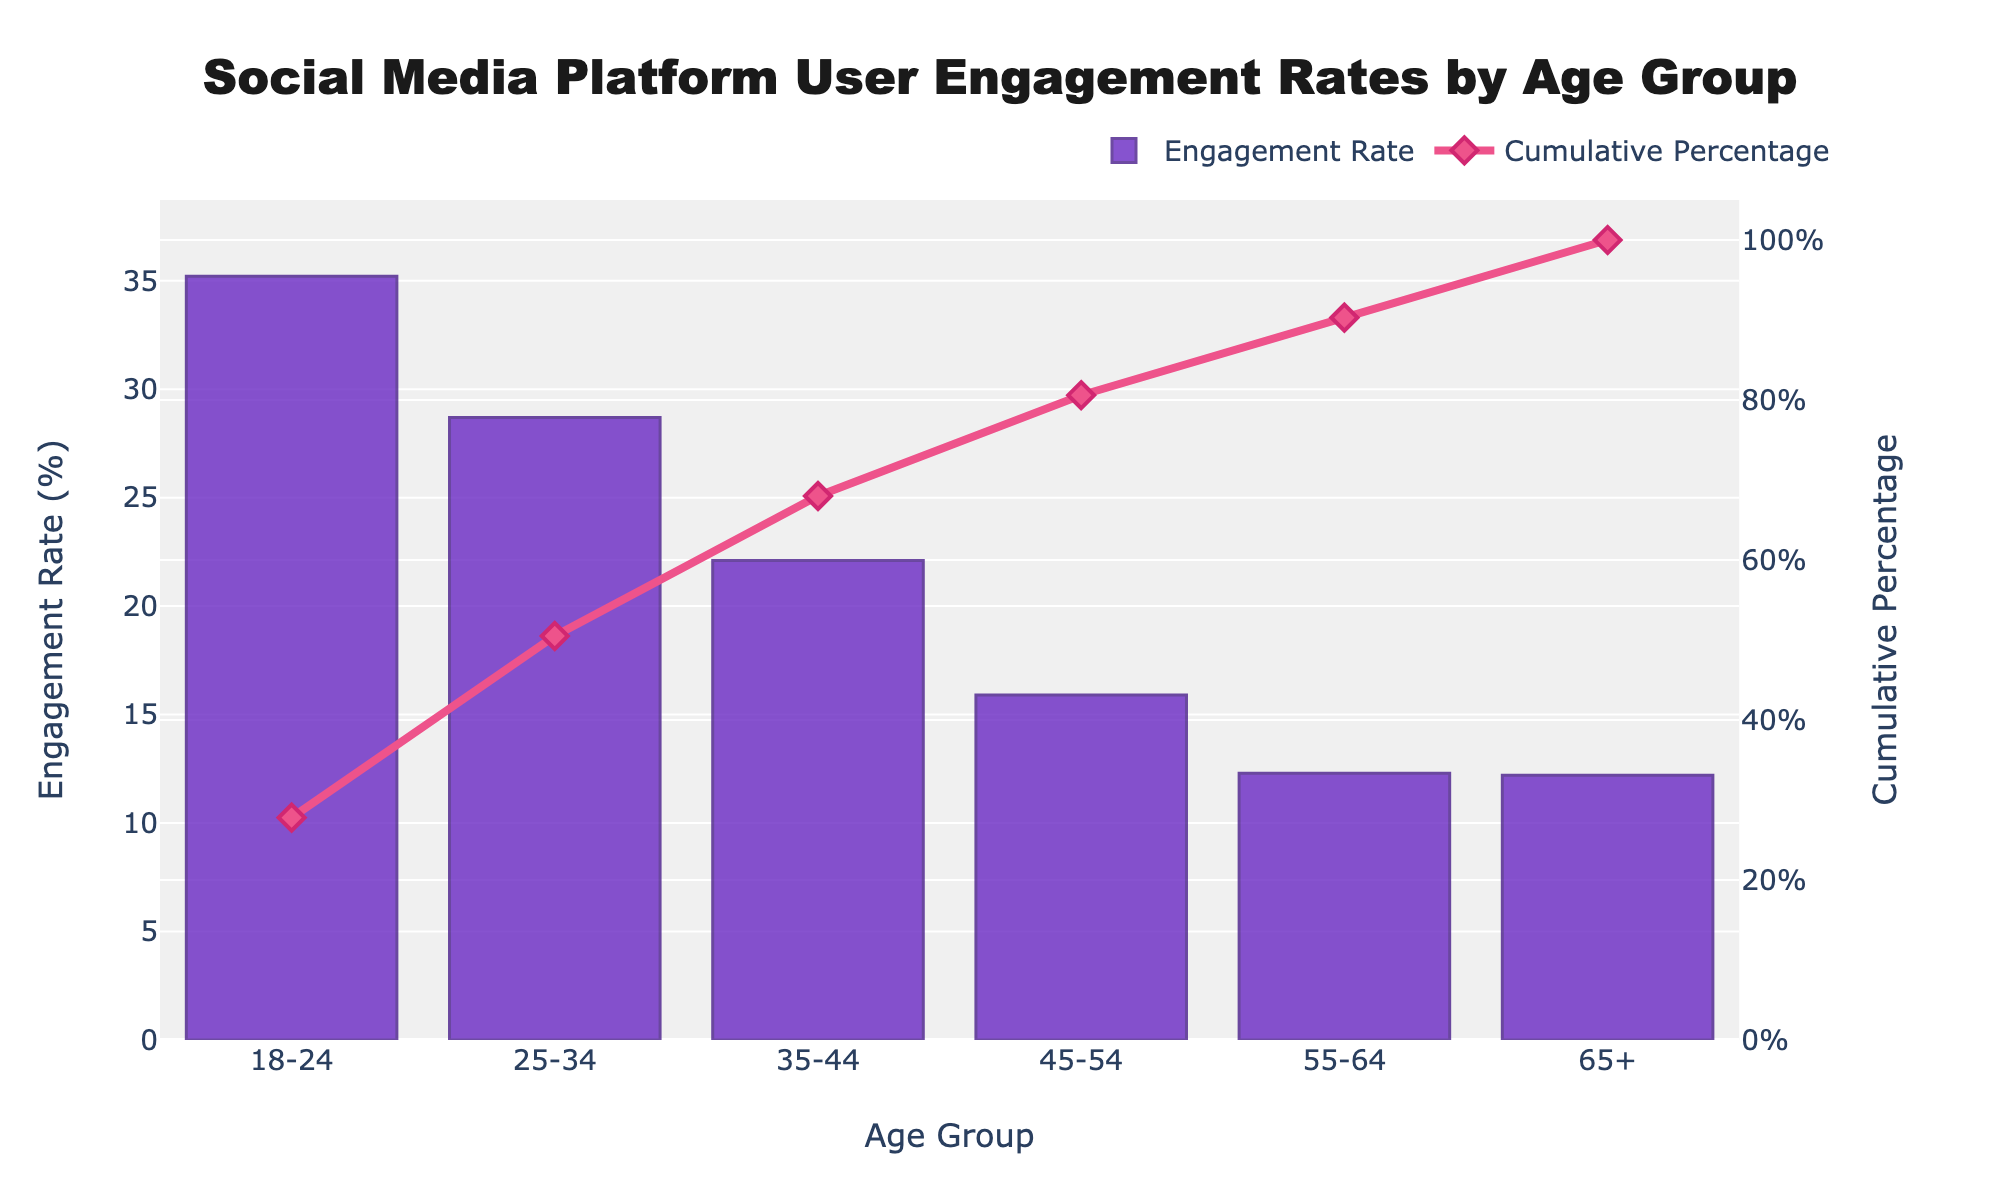What’s the title of the figure? The title is explicitly stated at the top center of the figure.
Answer: Social Media Platform User Engagement Rates by Age Group What is the engagement rate for the age group 25-34? Locate the bar representing the 25-34 age group on the x-axis and read the height of the bar on the y-axis, which represents the engagement rate.
Answer: 28.7% Which age group has the highest engagement rate? Identify the tallest bar, which corresponds to the age group with the highest engagement rate.
Answer: 18-24 What is the cumulative percentage for the age group 45-54? Find the point on the line chart corresponding to 45-54 on the x-axis, then read the cumulative percentage on the secondary y-axis.
Answer: 80.6% What is the difference in engagement rate between the age groups 18-24 and 35-44? Subtract the engagement rate of the 35-44 age group from that of the 18-24 age group: 35.2% - 22.1% = 13.1%.
Answer: 13.1% Which age group marks the point where the cumulative percentage exceeds 50%? Follow the cumulative percentage line until it crosses the 50% mark on the secondary y-axis. Identify the corresponding age group on the x-axis.
Answer: 25-34 How many age groups have an engagement rate greater than 20%? Count the bars with heights exceeding the 20% mark on the y-axis.
Answer: 3 What is the cumulative percentage for the last age group? Check the final point of the cumulative percentage line on the far right.
Answer: 100% Which age group had the smallest increase in cumulative percentage? Calculate the differences in cumulative percentage between consecutive age groups, then identify the smallest difference: 90.3% - 80.6% = 9.7%; 100% - 90.3% = 9.7%. Both indicate smallest increases for 55-64 and 65+
Answer: 55-64 and 65+ What engagement rates do the age groups 55-64 and 65+ share? Compare the heights of the bars for age groups 55-64 and 65+ on the y-axis. Both have nearly identical heights.
Answer: 12.3% and 12.2% 